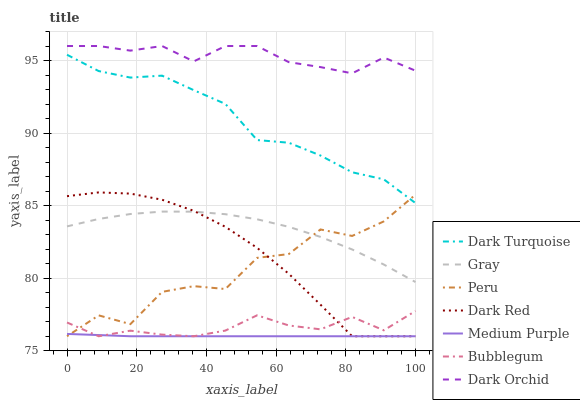Does Medium Purple have the minimum area under the curve?
Answer yes or no. Yes. Does Dark Orchid have the maximum area under the curve?
Answer yes or no. Yes. Does Dark Turquoise have the minimum area under the curve?
Answer yes or no. No. Does Dark Turquoise have the maximum area under the curve?
Answer yes or no. No. Is Medium Purple the smoothest?
Answer yes or no. Yes. Is Peru the roughest?
Answer yes or no. Yes. Is Dark Turquoise the smoothest?
Answer yes or no. No. Is Dark Turquoise the roughest?
Answer yes or no. No. Does Bubblegum have the lowest value?
Answer yes or no. Yes. Does Dark Turquoise have the lowest value?
Answer yes or no. No. Does Dark Orchid have the highest value?
Answer yes or no. Yes. Does Dark Turquoise have the highest value?
Answer yes or no. No. Is Bubblegum less than Dark Orchid?
Answer yes or no. Yes. Is Dark Orchid greater than Medium Purple?
Answer yes or no. Yes. Does Gray intersect Peru?
Answer yes or no. Yes. Is Gray less than Peru?
Answer yes or no. No. Is Gray greater than Peru?
Answer yes or no. No. Does Bubblegum intersect Dark Orchid?
Answer yes or no. No. 